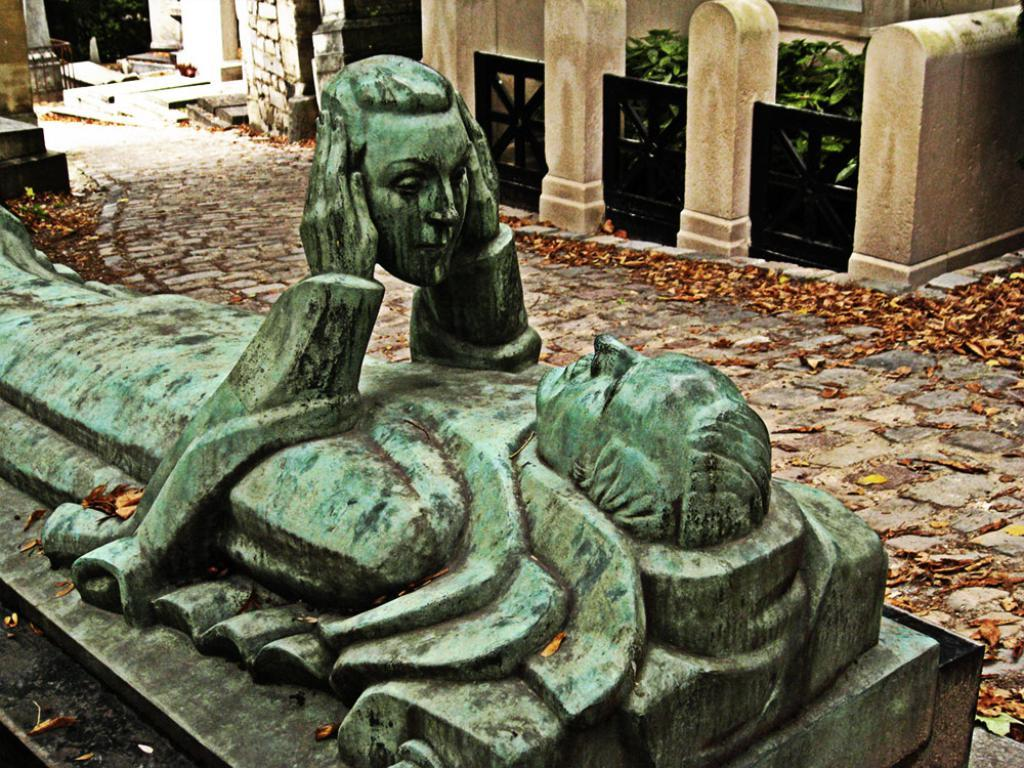What is the main subject of the image? There is a sculpture of a person in the middle of the image. What can be seen in the background of the image? There is a wall in the background of the image. What is the tendency of the sculpture to cough in the image? There is no indication of the sculpture coughing or having any tendencies in the image, as it is a static sculpture. 